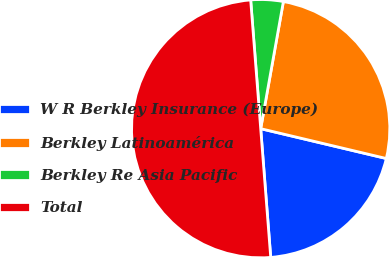<chart> <loc_0><loc_0><loc_500><loc_500><pie_chart><fcel>W R Berkley Insurance (Europe)<fcel>Berkley Latinoamérica<fcel>Berkley Re Asia Pacific<fcel>Total<nl><fcel>20.05%<fcel>25.9%<fcel>4.05%<fcel>50.0%<nl></chart> 